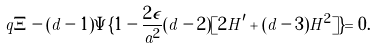<formula> <loc_0><loc_0><loc_500><loc_500>q \Xi - ( d - 1 ) \Psi \{ 1 - \frac { 2 \epsilon } { a ^ { 2 } } ( d - 2 ) [ 2 H ^ { \prime } + ( d - 3 ) H ^ { 2 } ] \} = 0 .</formula> 